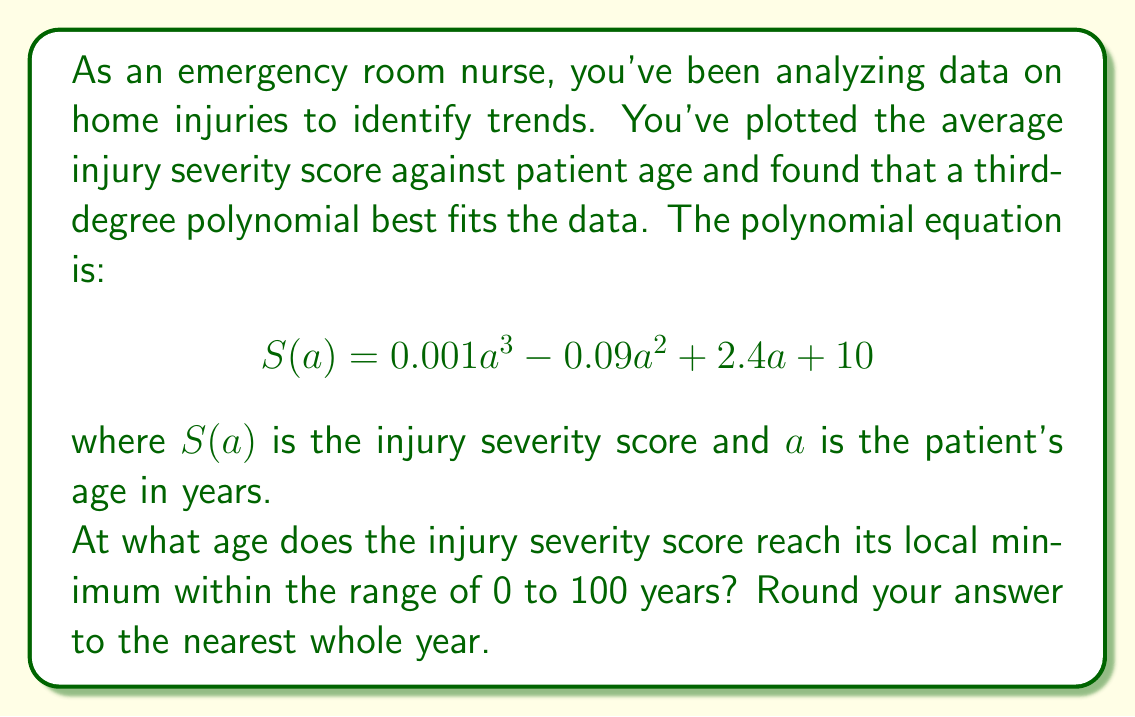Can you answer this question? To find the local minimum of the polynomial function, we need to follow these steps:

1) First, we need to find the derivative of the function $S(a)$:
   $$S'(a) = 0.003a^2 - 0.18a + 2.4$$

2) To find the critical points, we set $S'(a) = 0$ and solve for $a$:
   $$0.003a^2 - 0.18a + 2.4 = 0$$

3) This is a quadratic equation. We can solve it using the quadratic formula:
   $$a = \frac{-b \pm \sqrt{b^2 - 4ac}}{2a}$$
   where $a = 0.003$, $b = -0.18$, and $c = 2.4$

4) Plugging in these values:
   $$a = \frac{0.18 \pm \sqrt{(-0.18)^2 - 4(0.003)(2.4)}}{2(0.003)}$$
   $$= \frac{0.18 \pm \sqrt{0.0324 - 0.0288}}{0.006}$$
   $$= \frac{0.18 \pm \sqrt{0.0036}}{0.006}$$
   $$= \frac{0.18 \pm 0.06}{0.006}$$

5) This gives us two solutions:
   $$a_1 = \frac{0.18 + 0.06}{0.006} = 40$$
   $$a_2 = \frac{0.18 - 0.06}{0.006} = 20$$

6) To determine which of these is the minimum (rather than the maximum), we can check the second derivative:
   $$S''(a) = 0.006a - 0.18$$

7) Evaluating this at $a = 20$ and $a = 40$:
   $$S''(20) = 0.006(20) - 0.18 = -0.06 < 0$$
   $$S''(40) = 0.006(40) - 0.18 = 0.06 > 0$$

8) Since $S''(20) < 0$ and $S''(40) > 0$, the local minimum occurs at $a = 20$.

Therefore, the injury severity score reaches its local minimum at age 20 years.
Answer: 20 years 